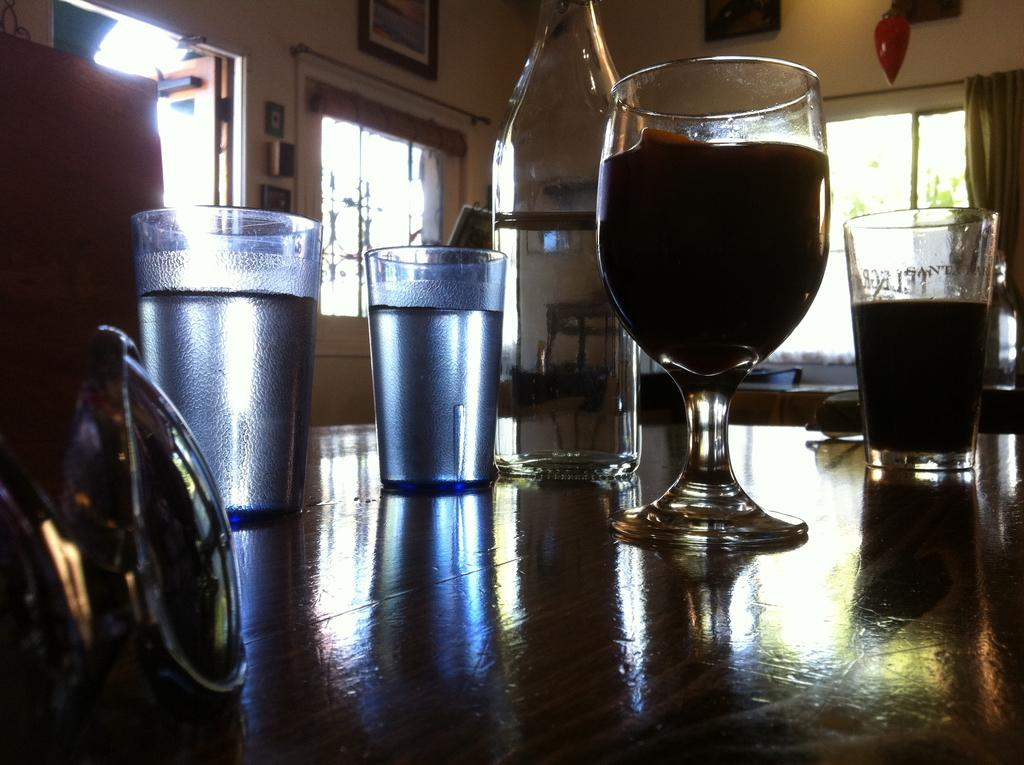How many glasses are visible in the image? There are 3 glasses in the image. Which type of glass is present among the 3 glasses? There is a wine glass in the image. Where are the glasses located? The glasses are on a table. What can be inferred about the location of the table? The table is inside a room. What additional features can be found in the room? The room has photos and windows. What caption is written on the queen's photo in the image? There is no queen or photo of a queen present in the image. 